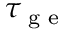<formula> <loc_0><loc_0><loc_500><loc_500>\tau _ { g e }</formula> 